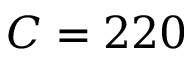<formula> <loc_0><loc_0><loc_500><loc_500>C = 2 2 0</formula> 